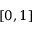Convert formula to latex. <formula><loc_0><loc_0><loc_500><loc_500>[ 0 , 1 ]</formula> 